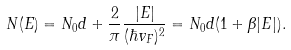Convert formula to latex. <formula><loc_0><loc_0><loc_500><loc_500>N ( E ) = N _ { 0 } d + \frac { 2 } { \pi } \frac { | E | } { ( \hbar { v } _ { F } ) ^ { 2 } } = N _ { 0 } d ( 1 + \beta | E | ) .</formula> 